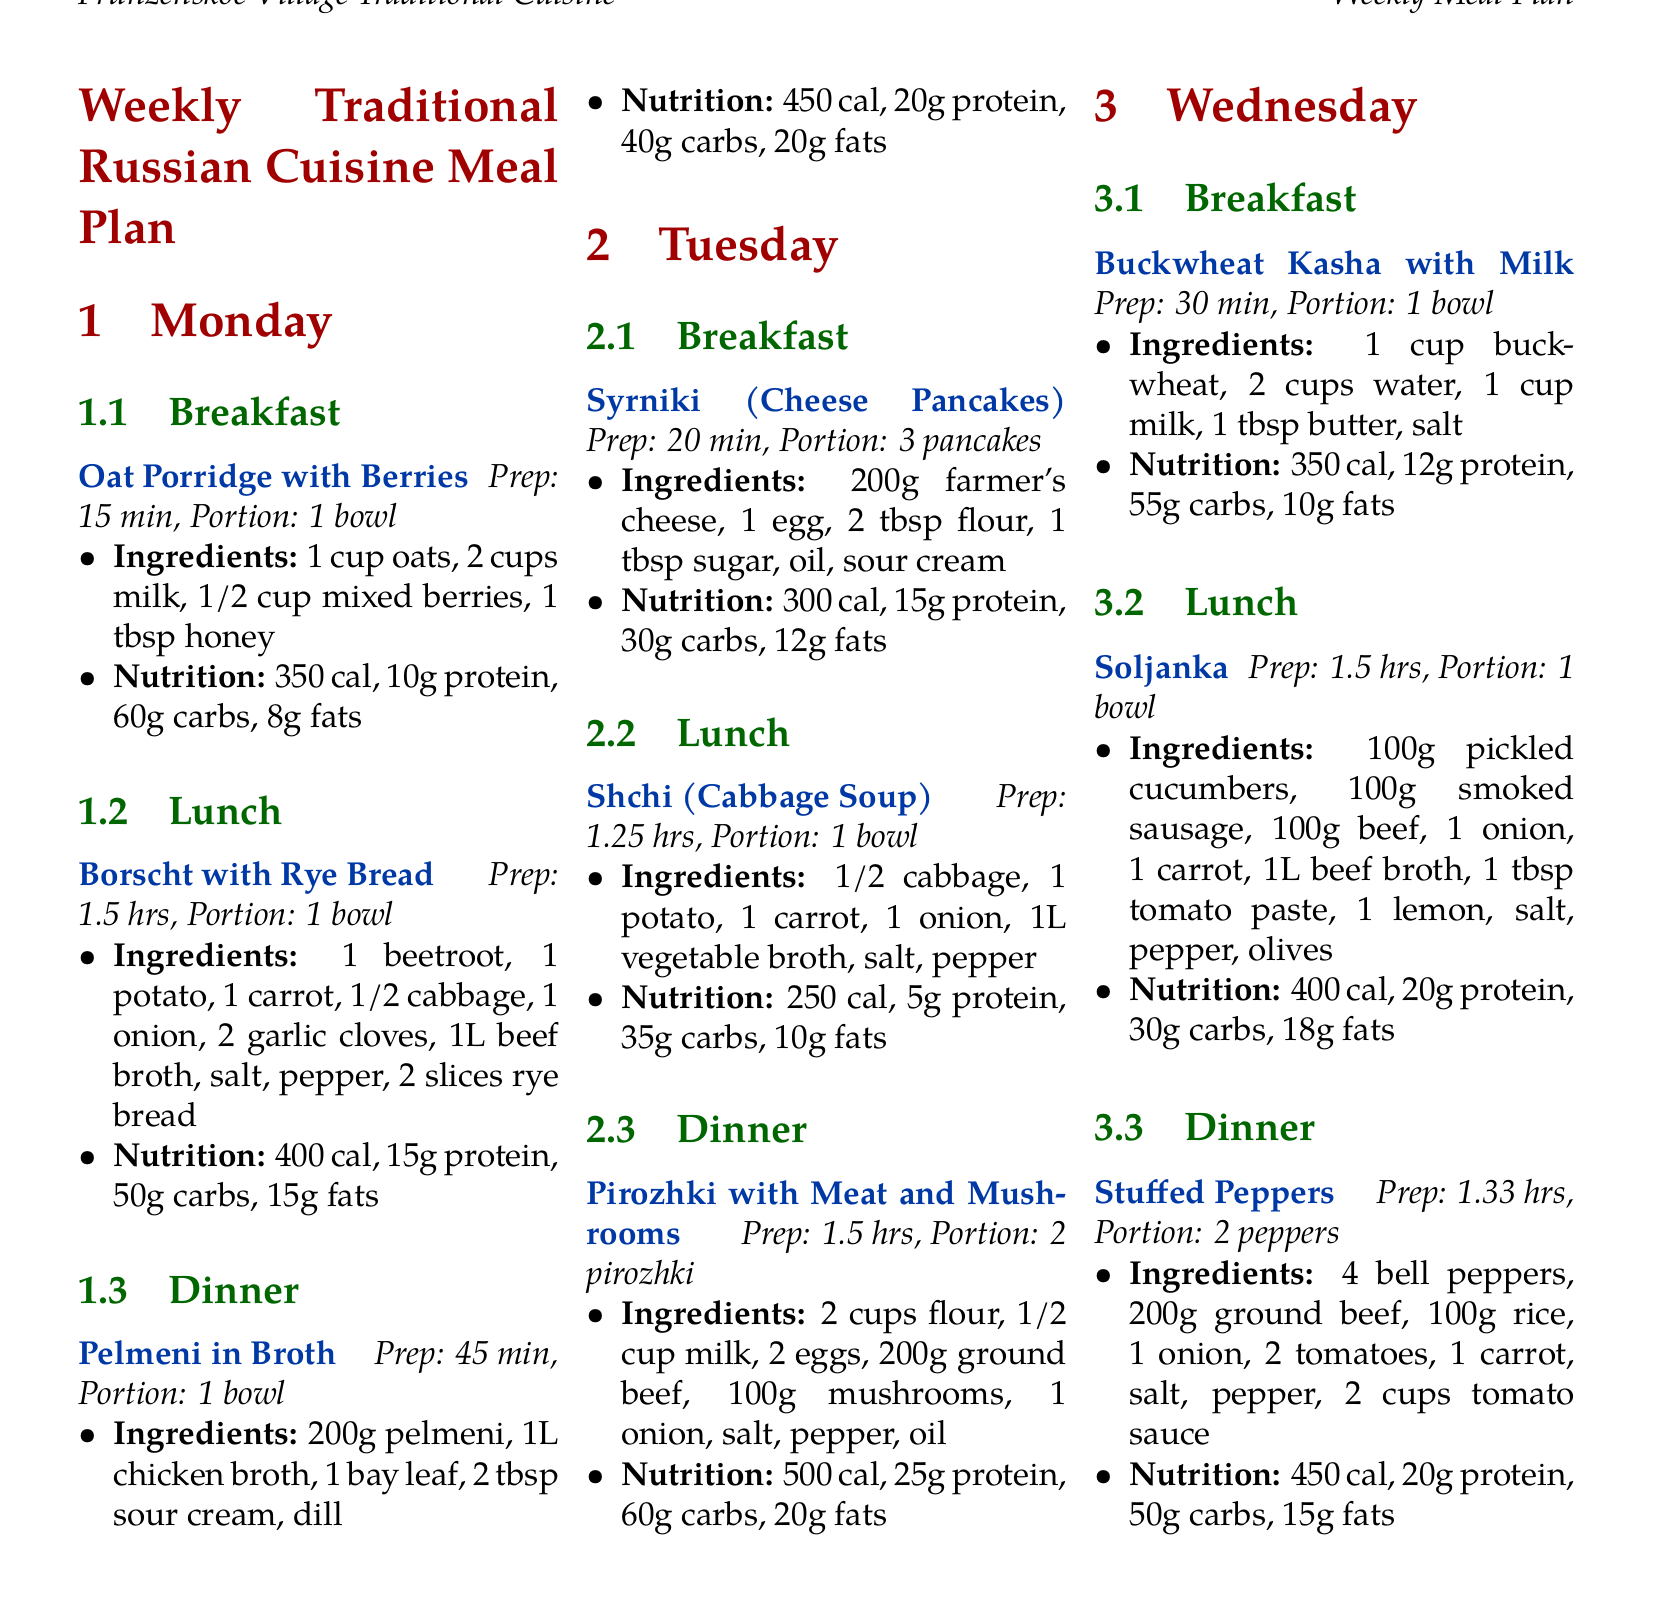what is the preparation time for borscht? The preparation time for borscht is specified as 1.5 hours in the document.
Answer: 1.5 hrs how many calories are in pirozhki with meat and mushrooms? The calorie count for pirozhki with meat and mushrooms is listed as 500 calories.
Answer: 500 cal which meal includes sour cream? The meals that include sour cream are pelmeni in broth and syrniki (cheese pancakes).
Answer: pelmeni in broth, syrniki what ingredients are used for oat porridge with berries? The ingredients for oat porridge with berries are noted in the document and include oats, milk, mixed berries, and honey.
Answer: 1 cup oats, 2 cups milk, 1/2 cup mixed berries, 1 tbsp honey how many grams of protein does stuffed peppers provide? The protein content for stuffed peppers is indicated as 20 grams in the nutritional information provided.
Answer: 20g protein what is the portion size for syrniki? The portion size for syrniki is noted in the document as 3 pancakes.
Answer: 3 pancakes which meal takes the longest to prepare on Tuesday? The meal that takes the longest to prepare on Tuesday is pirozhki with meat and mushrooms, which takes 1.5 hours.
Answer: pirozhki with meat and mushrooms how many carbs does soljanka have? The carbohydrate content for soljanka is specified as 30 grams in the corresponding information.
Answer: 30g carbs 